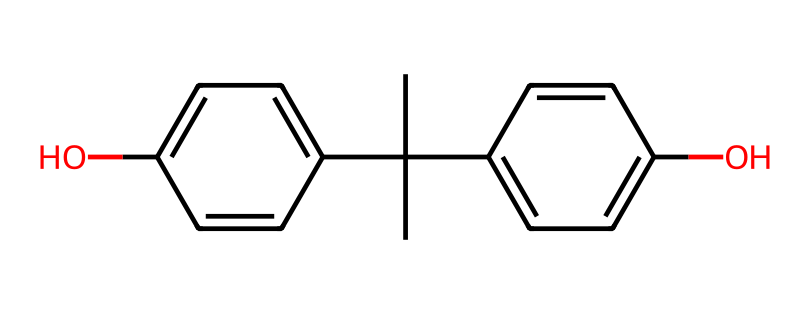What is the name of this chemical? The provided SMILES corresponds to bisphenol A, which is a well-known compound used in the production of plastics and resins.
Answer: bisphenol A How many carbon atoms are present? By analyzing the structure, you can count a total of 15 carbon atoms in the molecule, evident from the branching and ring structures.
Answer: 15 What type of functional groups can be identified in this structure? The structure contains hydroxyl groups (–OH) attached to two aromatic rings, characteristic of phenolic compounds.
Answer: hydroxyl groups Is this compound considered hazardous? Bisphenol A is classified as an endocrine disruptor and has been associated with various health risks, thereby qualifying it as hazardous.
Answer: yes How many rings are present in the molecular structure? The structure has two aromatic rings that are connected to the central carbon atom, clearly indicating the presence of two rings.
Answer: 2 What is the primary use of bisphenol A? Bisphenol A is primarily used in the production of polycarbonate plastics and epoxy resins, commonly found in coatings and adhesives.
Answer: plastics and resins 